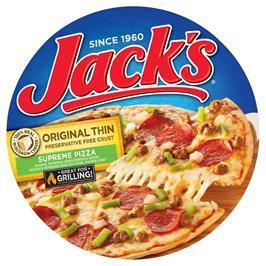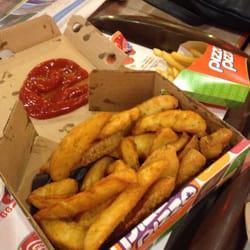The first image is the image on the left, the second image is the image on the right. Analyze the images presented: Is the assertion "One of the images shows pepperoni." valid? Answer yes or no. Yes. The first image is the image on the left, the second image is the image on the right. Considering the images on both sides, is "The left image includes a round shape with a type of pizza food depicted on it, and the right image shows fast food in a squarish container." valid? Answer yes or no. Yes. 